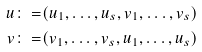Convert formula to latex. <formula><loc_0><loc_0><loc_500><loc_500>u \colon = & ( u _ { 1 } , \dots , u _ { s } , v _ { 1 } , \dots , v _ { s } ) \\ v \colon = & ( v _ { 1 } , \dots , v _ { s } , u _ { 1 } , \dots , u _ { s } )</formula> 